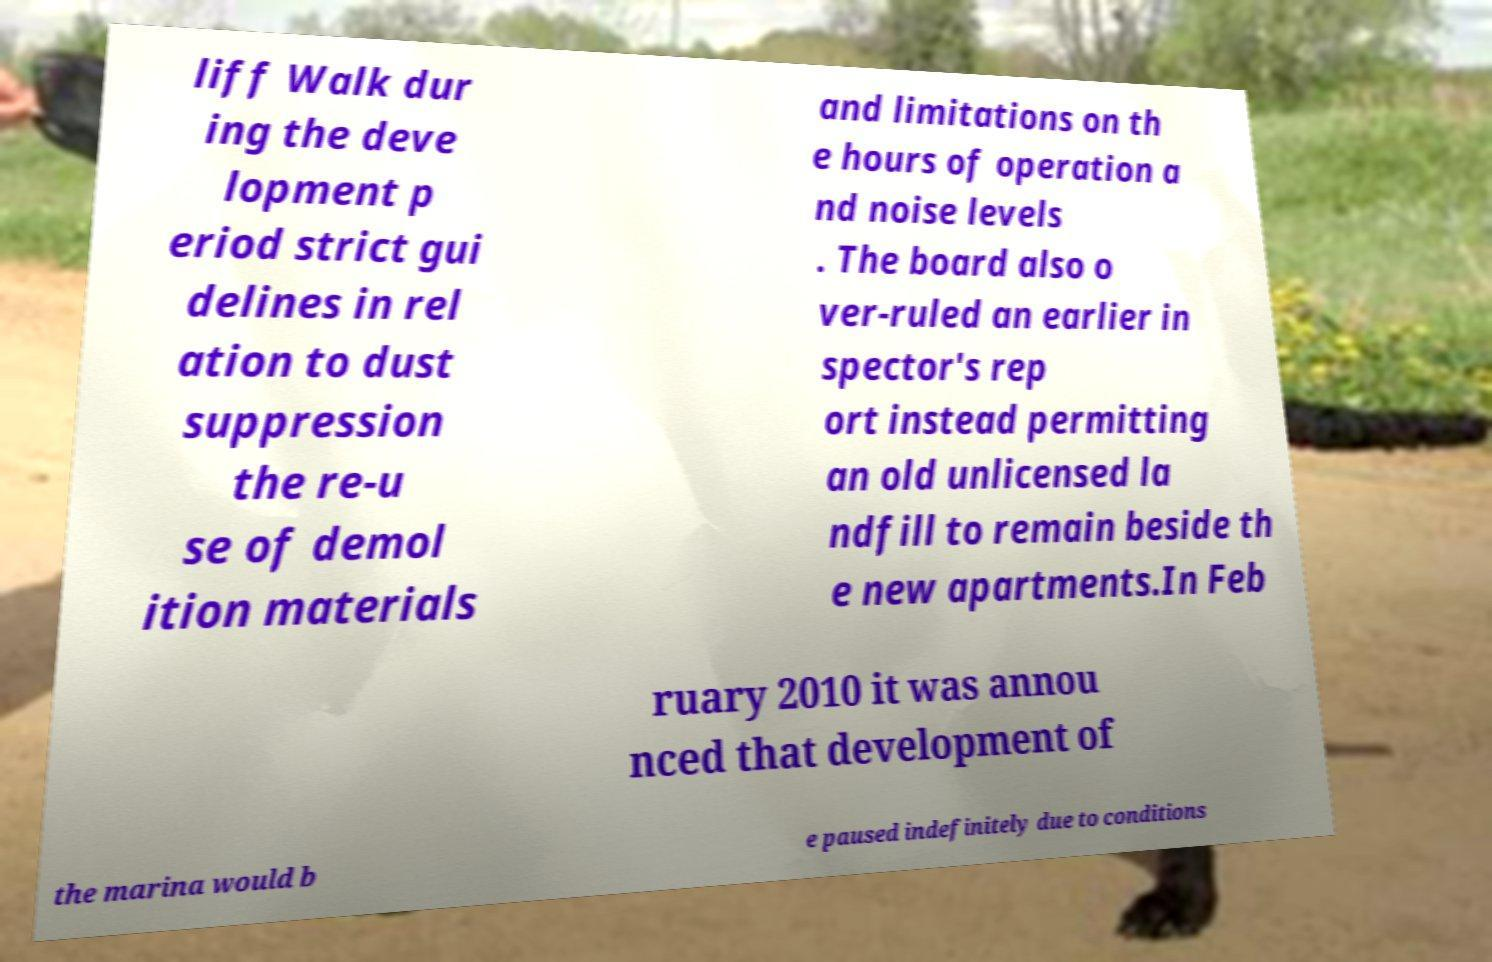Please read and relay the text visible in this image. What does it say? liff Walk dur ing the deve lopment p eriod strict gui delines in rel ation to dust suppression the re-u se of demol ition materials and limitations on th e hours of operation a nd noise levels . The board also o ver-ruled an earlier in spector's rep ort instead permitting an old unlicensed la ndfill to remain beside th e new apartments.In Feb ruary 2010 it was annou nced that development of the marina would b e paused indefinitely due to conditions 